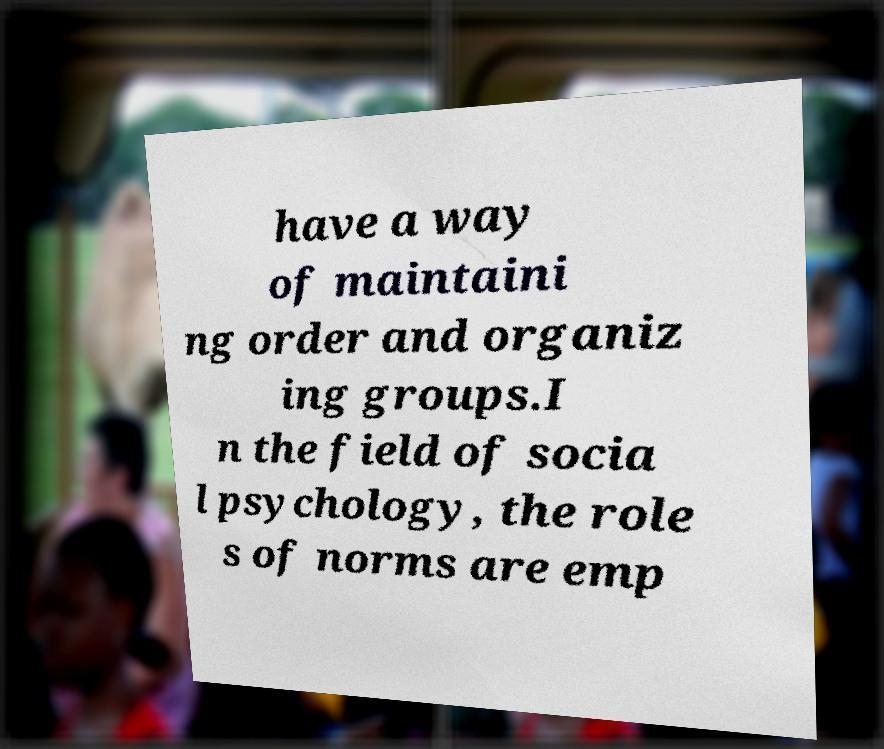I need the written content from this picture converted into text. Can you do that? have a way of maintaini ng order and organiz ing groups.I n the field of socia l psychology, the role s of norms are emp 